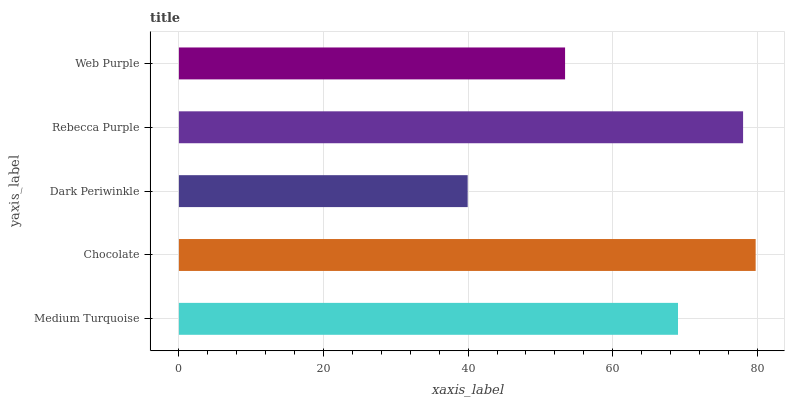Is Dark Periwinkle the minimum?
Answer yes or no. Yes. Is Chocolate the maximum?
Answer yes or no. Yes. Is Chocolate the minimum?
Answer yes or no. No. Is Dark Periwinkle the maximum?
Answer yes or no. No. Is Chocolate greater than Dark Periwinkle?
Answer yes or no. Yes. Is Dark Periwinkle less than Chocolate?
Answer yes or no. Yes. Is Dark Periwinkle greater than Chocolate?
Answer yes or no. No. Is Chocolate less than Dark Periwinkle?
Answer yes or no. No. Is Medium Turquoise the high median?
Answer yes or no. Yes. Is Medium Turquoise the low median?
Answer yes or no. Yes. Is Web Purple the high median?
Answer yes or no. No. Is Chocolate the low median?
Answer yes or no. No. 